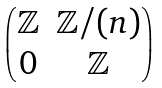<formula> <loc_0><loc_0><loc_500><loc_500>\begin{pmatrix} \mathbb { Z } & \mathbb { Z } / ( n ) \\ 0 & \mathbb { Z } \end{pmatrix}</formula> 